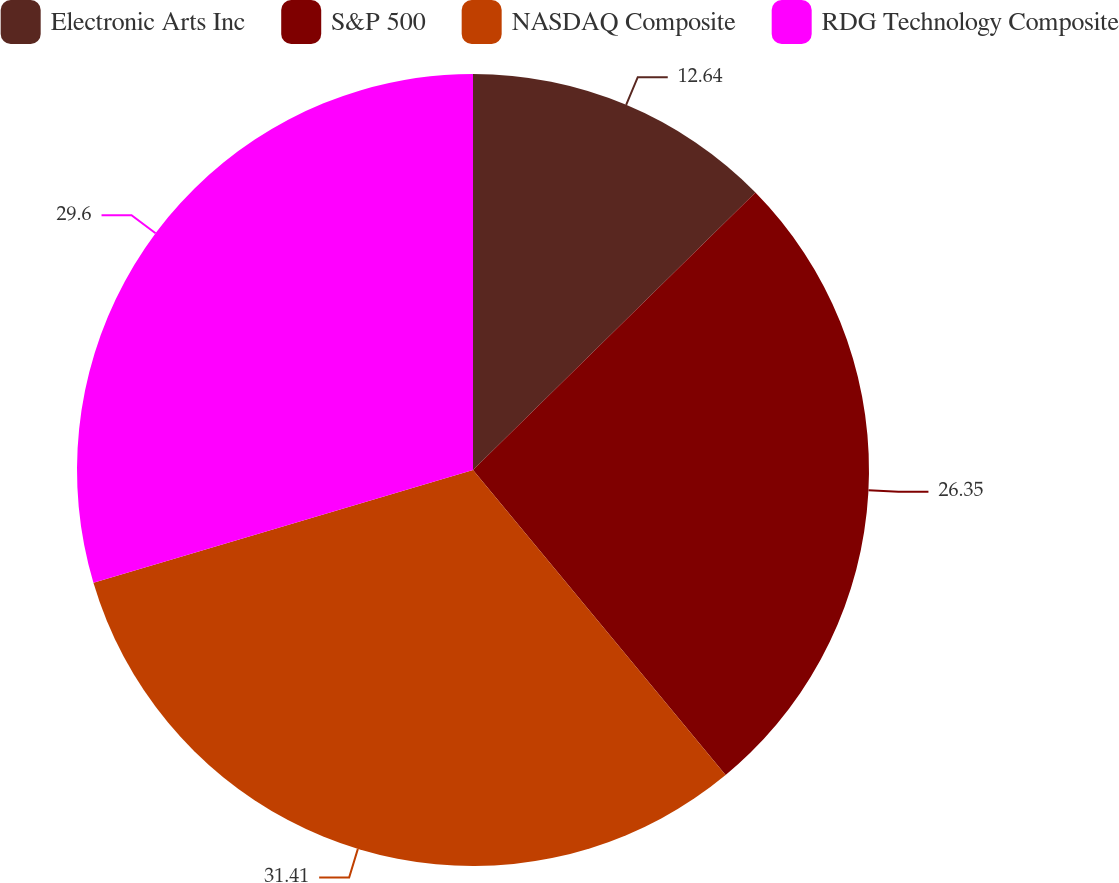Convert chart. <chart><loc_0><loc_0><loc_500><loc_500><pie_chart><fcel>Electronic Arts Inc<fcel>S&P 500<fcel>NASDAQ Composite<fcel>RDG Technology Composite<nl><fcel>12.64%<fcel>26.35%<fcel>31.41%<fcel>29.6%<nl></chart> 